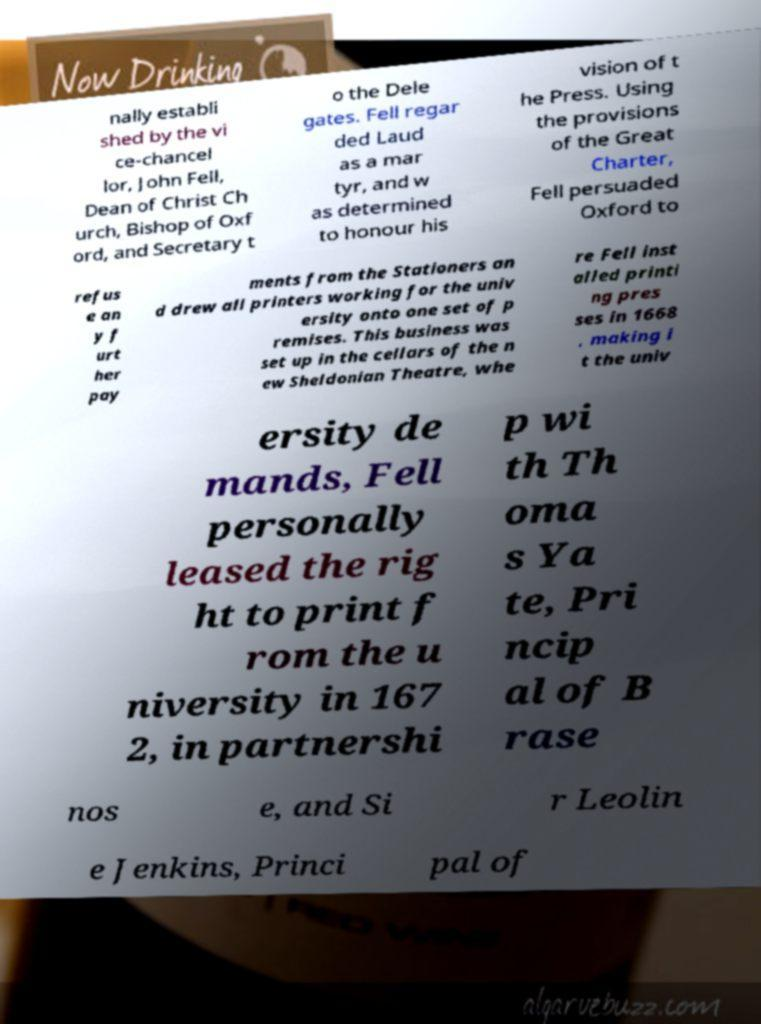Please read and relay the text visible in this image. What does it say? nally establi shed by the vi ce-chancel lor, John Fell, Dean of Christ Ch urch, Bishop of Oxf ord, and Secretary t o the Dele gates. Fell regar ded Laud as a mar tyr, and w as determined to honour his vision of t he Press. Using the provisions of the Great Charter, Fell persuaded Oxford to refus e an y f urt her pay ments from the Stationers an d drew all printers working for the univ ersity onto one set of p remises. This business was set up in the cellars of the n ew Sheldonian Theatre, whe re Fell inst alled printi ng pres ses in 1668 , making i t the univ ersity de mands, Fell personally leased the rig ht to print f rom the u niversity in 167 2, in partnershi p wi th Th oma s Ya te, Pri ncip al of B rase nos e, and Si r Leolin e Jenkins, Princi pal of 